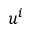<formula> <loc_0><loc_0><loc_500><loc_500>u ^ { i }</formula> 